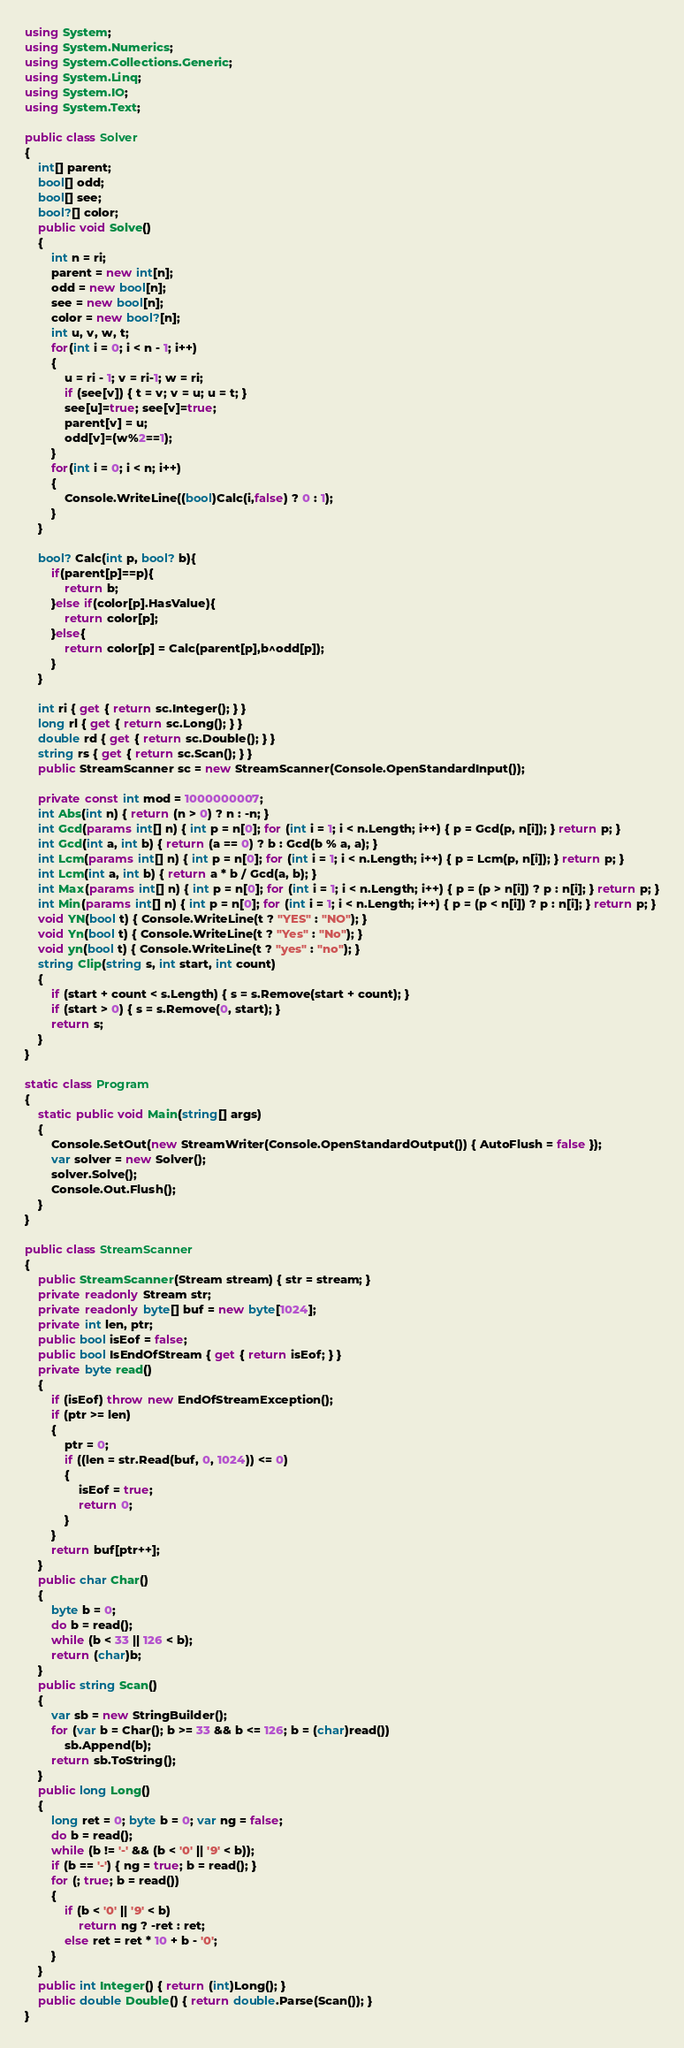<code> <loc_0><loc_0><loc_500><loc_500><_C#_>using System;
using System.Numerics;
using System.Collections.Generic;
using System.Linq;
using System.IO;
using System.Text;

public class Solver
{
    int[] parent;
    bool[] odd;
    bool[] see;
    bool?[] color;
    public void Solve()
    {
        int n = ri;
        parent = new int[n];
        odd = new bool[n];
        see = new bool[n];
        color = new bool?[n];
        int u, v, w, t;
        for(int i = 0; i < n - 1; i++)
        {
            u = ri - 1; v = ri-1; w = ri;
            if (see[v]) { t = v; v = u; u = t; }
            see[u]=true; see[v]=true;
            parent[v] = u;
            odd[v]=(w%2==1);
        }
        for(int i = 0; i < n; i++)
        {
            Console.WriteLine((bool)Calc(i,false) ? 0 : 1);
        }
    }
  
    bool? Calc(int p, bool? b){
        if(parent[p]==p){
            return b;
        }else if(color[p].HasValue){
            return color[p];
        }else{
            return color[p] = Calc(parent[p],b^odd[p]);
        }
    }

    int ri { get { return sc.Integer(); } }
    long rl { get { return sc.Long(); } }
    double rd { get { return sc.Double(); } }
    string rs { get { return sc.Scan(); } }
    public StreamScanner sc = new StreamScanner(Console.OpenStandardInput());

    private const int mod = 1000000007;
    int Abs(int n) { return (n > 0) ? n : -n; }
    int Gcd(params int[] n) { int p = n[0]; for (int i = 1; i < n.Length; i++) { p = Gcd(p, n[i]); } return p; }
    int Gcd(int a, int b) { return (a == 0) ? b : Gcd(b % a, a); }
    int Lcm(params int[] n) { int p = n[0]; for (int i = 1; i < n.Length; i++) { p = Lcm(p, n[i]); } return p; }
    int Lcm(int a, int b) { return a * b / Gcd(a, b); }
    int Max(params int[] n) { int p = n[0]; for (int i = 1; i < n.Length; i++) { p = (p > n[i]) ? p : n[i]; } return p; }
    int Min(params int[] n) { int p = n[0]; for (int i = 1; i < n.Length; i++) { p = (p < n[i]) ? p : n[i]; } return p; }
    void YN(bool t) { Console.WriteLine(t ? "YES" : "NO"); }
    void Yn(bool t) { Console.WriteLine(t ? "Yes" : "No"); }
    void yn(bool t) { Console.WriteLine(t ? "yes" : "no"); }
    string Clip(string s, int start, int count)
    {
        if (start + count < s.Length) { s = s.Remove(start + count); }
        if (start > 0) { s = s.Remove(0, start); }
        return s;
    }
}

static class Program
{
    static public void Main(string[] args)
    {
        Console.SetOut(new StreamWriter(Console.OpenStandardOutput()) { AutoFlush = false });
        var solver = new Solver();
        solver.Solve();
        Console.Out.Flush();
    }
}

public class StreamScanner
{
    public StreamScanner(Stream stream) { str = stream; }
    private readonly Stream str;
    private readonly byte[] buf = new byte[1024];
    private int len, ptr;
    public bool isEof = false;
    public bool IsEndOfStream { get { return isEof; } }
    private byte read()
    {
        if (isEof) throw new EndOfStreamException();
        if (ptr >= len)
        {
            ptr = 0;
            if ((len = str.Read(buf, 0, 1024)) <= 0)
            {
                isEof = true;
                return 0;
            }
        }
        return buf[ptr++];
    }
    public char Char()
    {
        byte b = 0;
        do b = read();
        while (b < 33 || 126 < b);
        return (char)b;
    }
    public string Scan()
    {
        var sb = new StringBuilder();
        for (var b = Char(); b >= 33 && b <= 126; b = (char)read())
            sb.Append(b);
        return sb.ToString();
    }
    public long Long()
    {
        long ret = 0; byte b = 0; var ng = false;
        do b = read();
        while (b != '-' && (b < '0' || '9' < b));
        if (b == '-') { ng = true; b = read(); }
        for (; true; b = read())
        {
            if (b < '0' || '9' < b)
                return ng ? -ret : ret;
            else ret = ret * 10 + b - '0';
        }
    }
    public int Integer() { return (int)Long(); }
    public double Double() { return double.Parse(Scan()); }
}
</code> 